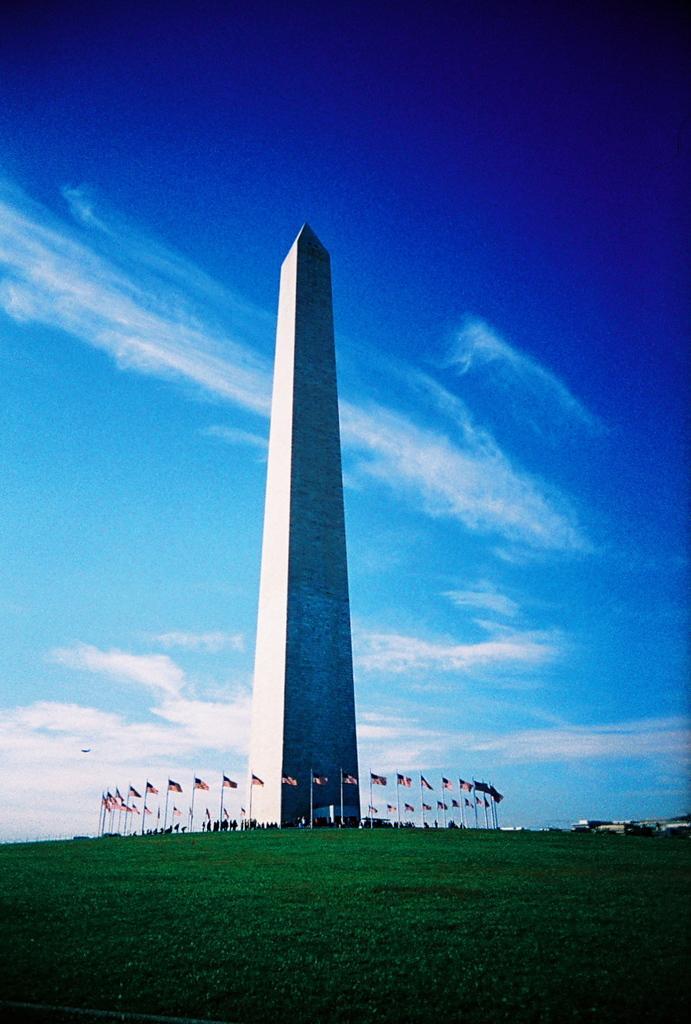Can you describe this image briefly? In the center of the image there is a memorial. There are flags around it. At the bottom of the image there is grass. In the background of the image there is sky. 